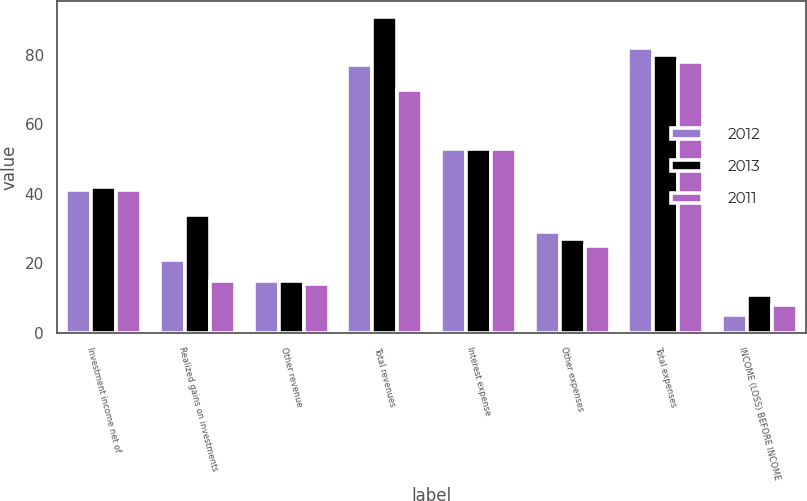Convert chart to OTSL. <chart><loc_0><loc_0><loc_500><loc_500><stacked_bar_chart><ecel><fcel>Investment income net of<fcel>Realized gains on investments<fcel>Other revenue<fcel>Total revenues<fcel>Interest expense<fcel>Other expenses<fcel>Total expenses<fcel>INCOME (LOSS) BEFORE INCOME<nl><fcel>2012<fcel>41<fcel>21<fcel>15<fcel>77<fcel>53<fcel>29<fcel>82<fcel>5<nl><fcel>2013<fcel>42<fcel>34<fcel>15<fcel>91<fcel>53<fcel>27<fcel>80<fcel>11<nl><fcel>2011<fcel>41<fcel>15<fcel>14<fcel>70<fcel>53<fcel>25<fcel>78<fcel>8<nl></chart> 